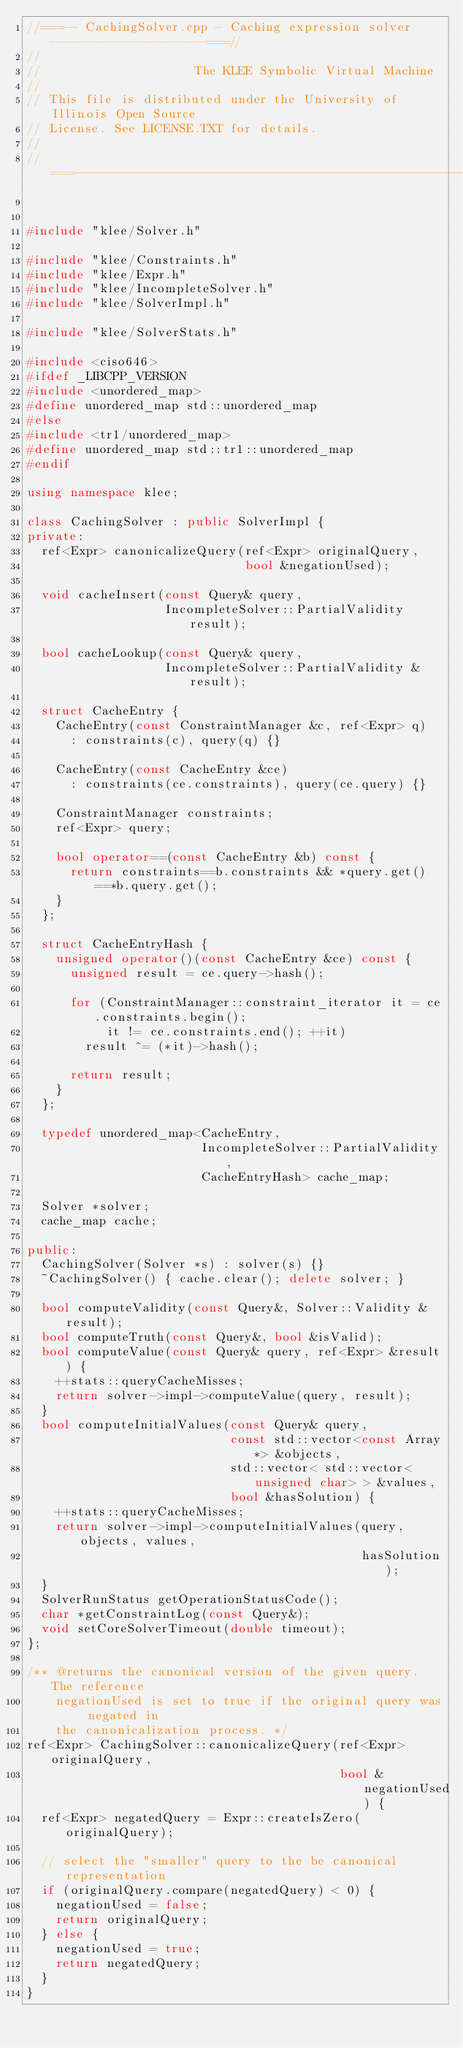Convert code to text. <code><loc_0><loc_0><loc_500><loc_500><_C++_>//===-- CachingSolver.cpp - Caching expression solver ---------------------===//
//
//                     The KLEE Symbolic Virtual Machine
//
// This file is distributed under the University of Illinois Open Source
// License. See LICENSE.TXT for details.
//
//===----------------------------------------------------------------------===//


#include "klee/Solver.h"

#include "klee/Constraints.h"
#include "klee/Expr.h"
#include "klee/IncompleteSolver.h"
#include "klee/SolverImpl.h"

#include "klee/SolverStats.h"

#include <ciso646>
#ifdef _LIBCPP_VERSION
#include <unordered_map>
#define unordered_map std::unordered_map
#else
#include <tr1/unordered_map>
#define unordered_map std::tr1::unordered_map
#endif

using namespace klee;

class CachingSolver : public SolverImpl {
private:
  ref<Expr> canonicalizeQuery(ref<Expr> originalQuery,
                              bool &negationUsed);

  void cacheInsert(const Query& query,
                   IncompleteSolver::PartialValidity result);

  bool cacheLookup(const Query& query,
                   IncompleteSolver::PartialValidity &result);
  
  struct CacheEntry {
    CacheEntry(const ConstraintManager &c, ref<Expr> q)
      : constraints(c), query(q) {}

    CacheEntry(const CacheEntry &ce)
      : constraints(ce.constraints), query(ce.query) {}
    
    ConstraintManager constraints;
    ref<Expr> query;

    bool operator==(const CacheEntry &b) const {
      return constraints==b.constraints && *query.get()==*b.query.get();
    }
  };
  
  struct CacheEntryHash {
    unsigned operator()(const CacheEntry &ce) const {
      unsigned result = ce.query->hash();
      
      for (ConstraintManager::constraint_iterator it = ce.constraints.begin();
           it != ce.constraints.end(); ++it)
        result ^= (*it)->hash();
      
      return result;
    }
  };

  typedef unordered_map<CacheEntry, 
                        IncompleteSolver::PartialValidity, 
                        CacheEntryHash> cache_map;
  
  Solver *solver;
  cache_map cache;

public:
  CachingSolver(Solver *s) : solver(s) {}
  ~CachingSolver() { cache.clear(); delete solver; }

  bool computeValidity(const Query&, Solver::Validity &result);
  bool computeTruth(const Query&, bool &isValid);
  bool computeValue(const Query& query, ref<Expr> &result) {
    ++stats::queryCacheMisses;
    return solver->impl->computeValue(query, result);
  }
  bool computeInitialValues(const Query& query,
                            const std::vector<const Array*> &objects,
                            std::vector< std::vector<unsigned char> > &values,
                            bool &hasSolution) {
    ++stats::queryCacheMisses;
    return solver->impl->computeInitialValues(query, objects, values, 
                                              hasSolution);
  }
  SolverRunStatus getOperationStatusCode();
  char *getConstraintLog(const Query&);
  void setCoreSolverTimeout(double timeout);
};

/** @returns the canonical version of the given query.  The reference
    negationUsed is set to true if the original query was negated in
    the canonicalization process. */
ref<Expr> CachingSolver::canonicalizeQuery(ref<Expr> originalQuery,
                                           bool &negationUsed) {
  ref<Expr> negatedQuery = Expr::createIsZero(originalQuery);

  // select the "smaller" query to the be canonical representation
  if (originalQuery.compare(negatedQuery) < 0) {
    negationUsed = false;
    return originalQuery;
  } else {
    negationUsed = true;
    return negatedQuery;
  }
}
</code> 